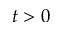<formula> <loc_0><loc_0><loc_500><loc_500>t > 0</formula> 